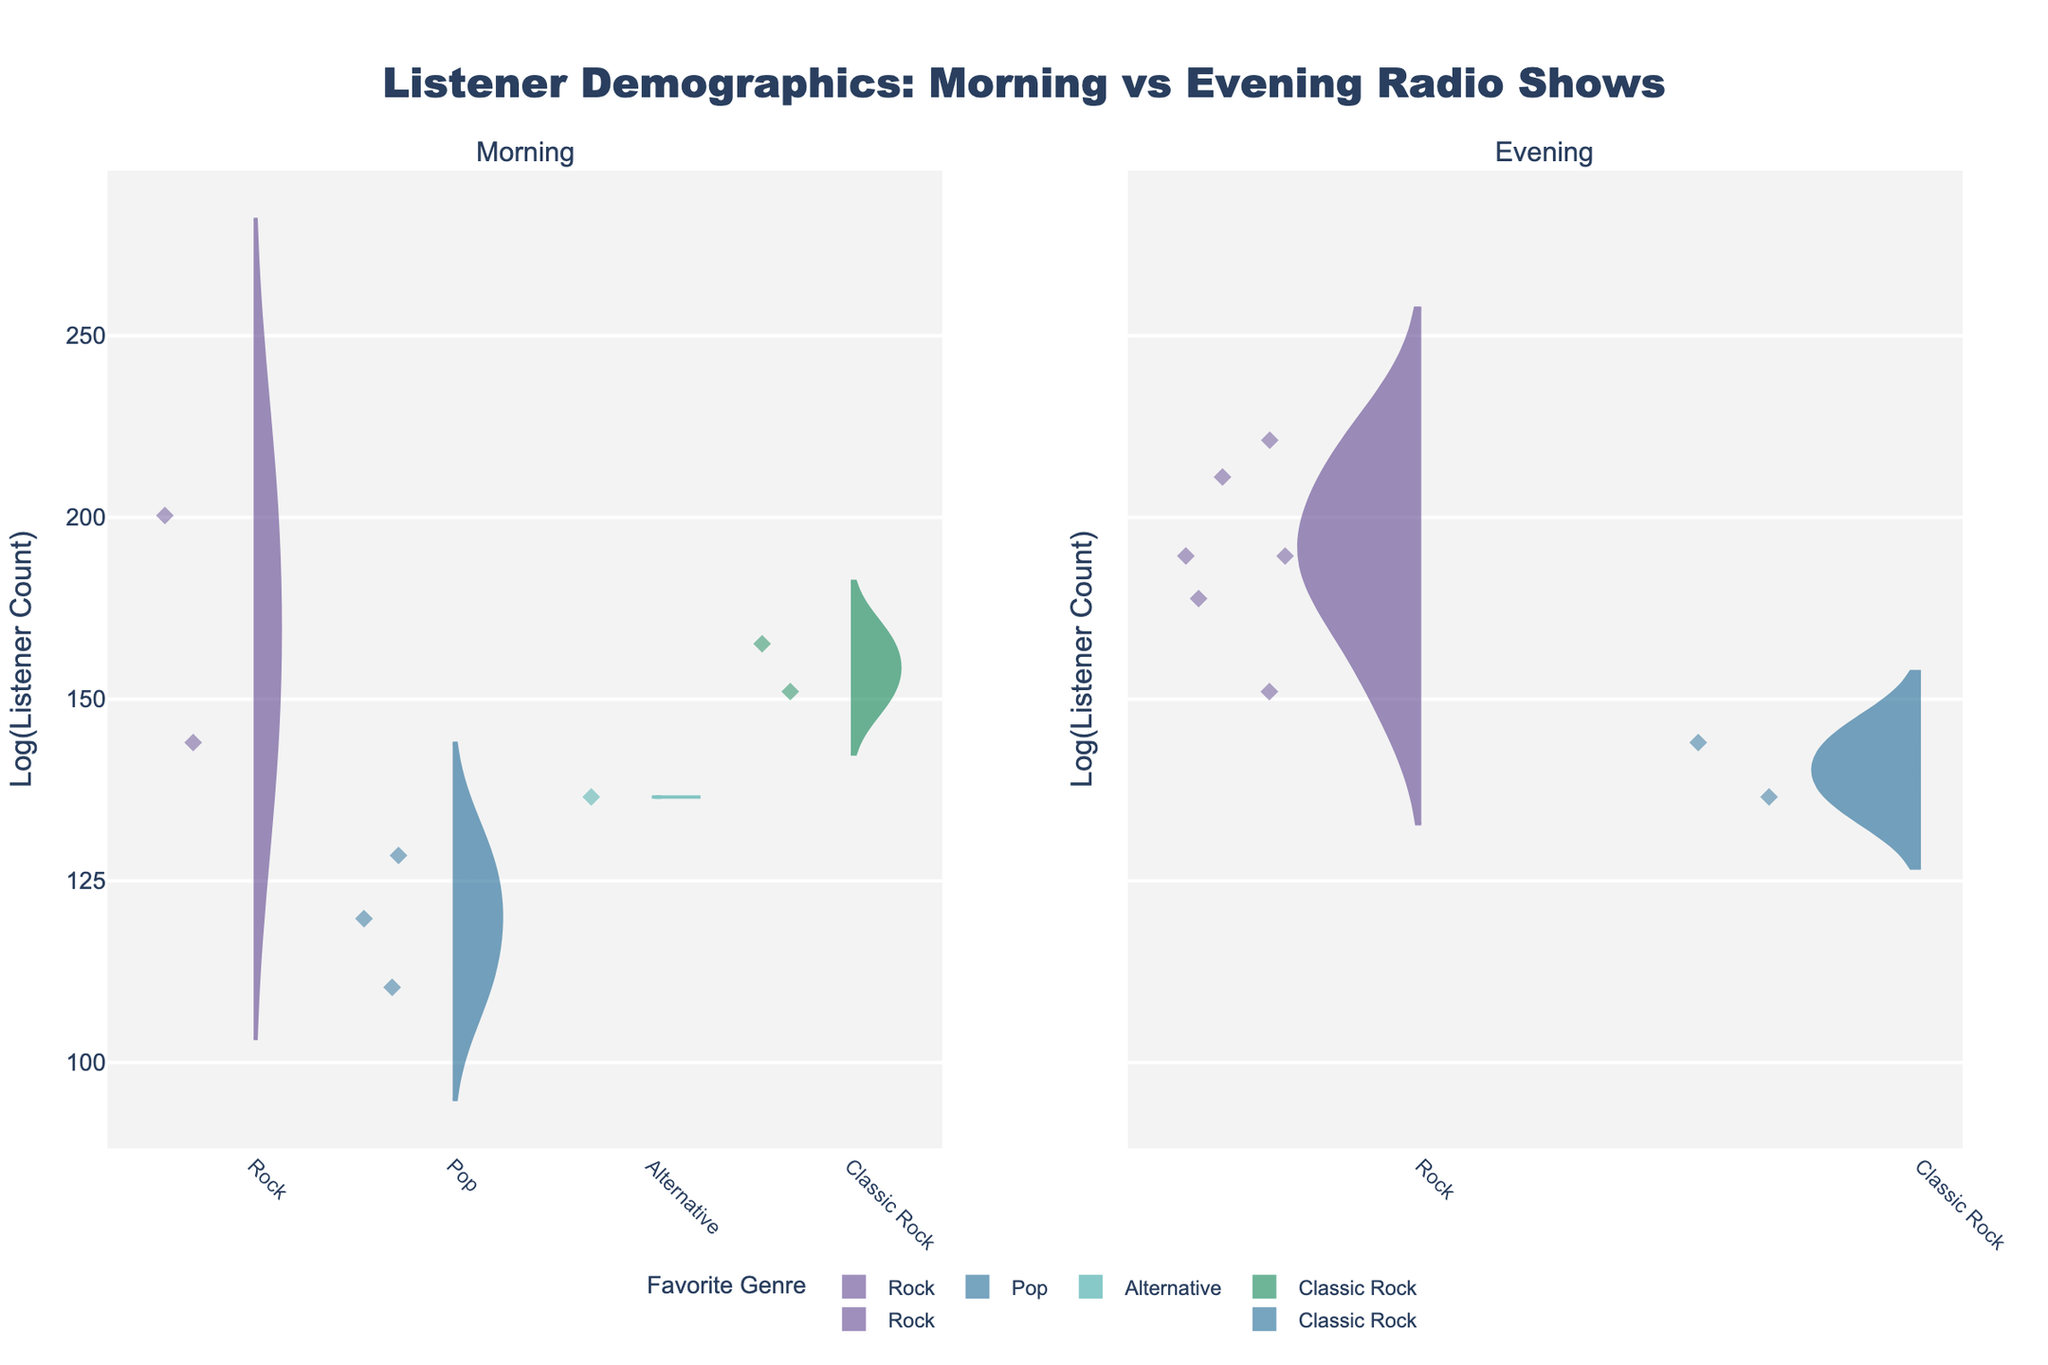What is the title of the figure? The title is often displayed prominently at the top of the figure and provides a summary of the visualized data. The title here is "Listener Demographics: Morning vs Evening Radio Shows."
Answer: Listener Demographics: Morning vs Evening Radio Shows How many favorite genres are represented in the Morning time slot? Inspect the left subplot labeled "Morning" to count the distinct genres. The distinct genres include Rock, Pop, Alternative, Classic Rock.
Answer: 4 Which favorite genre has the highest listener count in the Evening time slot? Observe the right subplot labeled "Evening" and compare the heights of the violin plots. Rock has the tallest violin plot, indicating the highest listener count.
Answer: Rock Are there more listeners in the 18-24 age group in the morning or the evening? Compare the violin plots for the 18-24 age group between the two time slots. The evening slot has taller and broader plots indicating more listeners.
Answer: Evening Which time slot has more variety in listener favorite genres? Compare the number of distinct violin plots in both the Morning and Evening subplots. Both time slots have 4 different genres, indicating equal variety.
Answer: Neither; they have the same variety How does the listener count for "Alternative" in the Morning compare to "Classic Rock" in the Evening for the 25-34 age group? Referring to both violin plots:
- "Alternative" in Morning (25-34): Located in the index position for the Morning slot.
- "Classic Rock" in Evening (25-34): Located in the Evening slot. "Classic Rock" has taller violins indicating higher counts.
Therefore, "Classic Rock" in the Evening has higher counts.
Answer: Classic Rock in the Evening is higher Which gender has more variety in favorite genres in the Evening time slot? Examine Evening violin plot colors: 
- Male preferences: Rock (multiple instances)
- Female preferences: Rock, Classic Rock
Hence, female listeners show more variety in genres.
Answer: Female What is the most favorite genre for female listeners in the Morning slot between the ages 25-34? Locate the Morning slot, identify "Alternative" as favored by women aged 25-34.
Answer: Alternative Do listeners aged 35-44 prefer Rock more in the Morning or Evening? Compare "Rock" violin plots:
- Morning: No apparent tall Rock plot
- Evening: Proportionally higher listener count
Thus, Rock is preferred more in the Evening slot.
Answer: Evening 